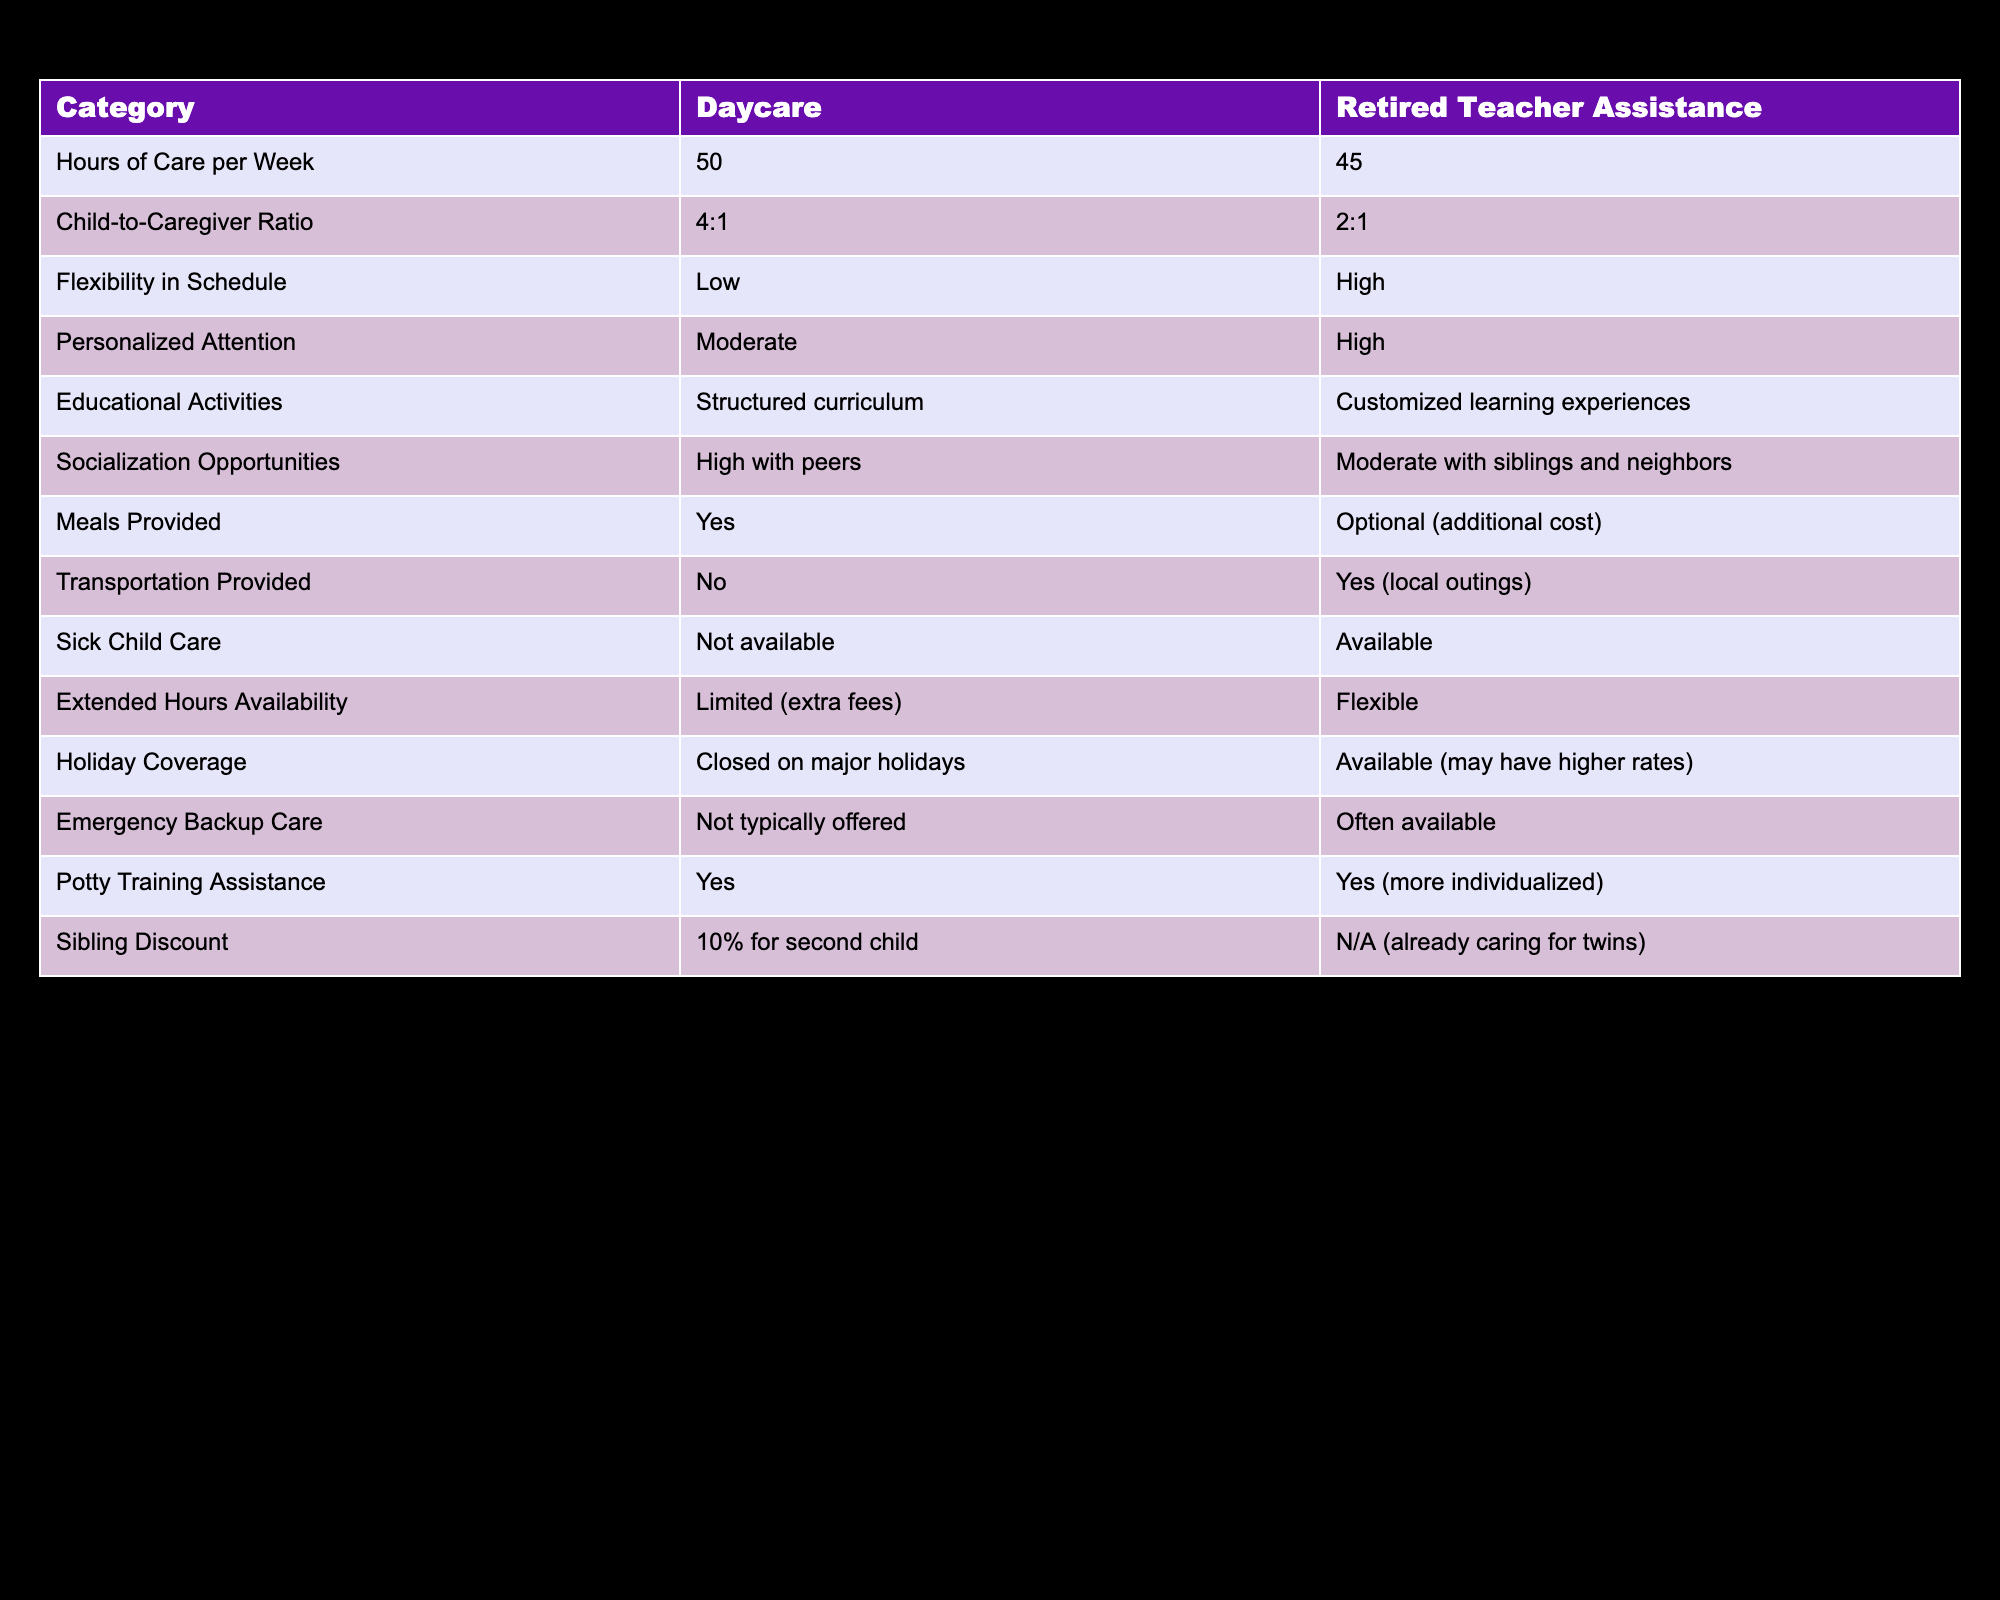What are the hours of care provided by daycare? The table shows that daycare provides 50 hours of care per week.
Answer: 50 Is the child-to-caregiver ratio better with retired teacher assistance? The table reveals a ratio of 2:1 for retired teacher assistance compared to 4:1 in daycare, indicating better attention.
Answer: Yes How many more hours of care does daycare offer compared to retired teacher assistance? Daycare offers 50 hours, while retired teacher assistance provides 45 hours. The difference is 50 - 45 = 5 hours.
Answer: 5 hours Does retired teacher assistance offer emergency backup care? The table indicates that emergency backup care is often available with retired teacher assistance, but not typically offered by daycare.
Answer: Yes What is one key benefit of choosing retired teacher assistance over daycare? Retired teacher assistance offers high flexibility in schedule and personalized attention, while daycare has low flexibility and moderate personalized attention.
Answer: High flexibility and personalized attention How does the availability of sick child care compare between daycare and retired teacher assistance? The table states that daycare does not provide sick child care, while retired teacher assistance does. Thus, retired teacher assistance is better in this aspect.
Answer: Retired teacher assistance offers sick child care What is the total ratio of caregivers to children between both options? With daycare having 4 children per caregiver (4:1) and retired teacher assistance having 2 children per caregiver (2:1), we calculate the total caregivers if both were to care for a total of 6 children (twins having more personalized care). Thus, daycare would have 1.5 caregivers (6/4) and retired teacher assistance would have 3 caregivers (6/2) available for the twins. The total caregiver ratio is 1.5 + 3 = 4.5 children per caregiver.
Answer: 4.5 children per caregiver Is transportation provided by daycare? The table states that daycare does not provide transportation, while retired teacher assistance does, making this a no for daycare.
Answer: No Would you receive meals included in retired teacher assistance? The table indicates that meals are optional and come with additional costs when opting for retired teacher assistance, whereas daycare provides meals. Thus, meals are not included.
Answer: No 